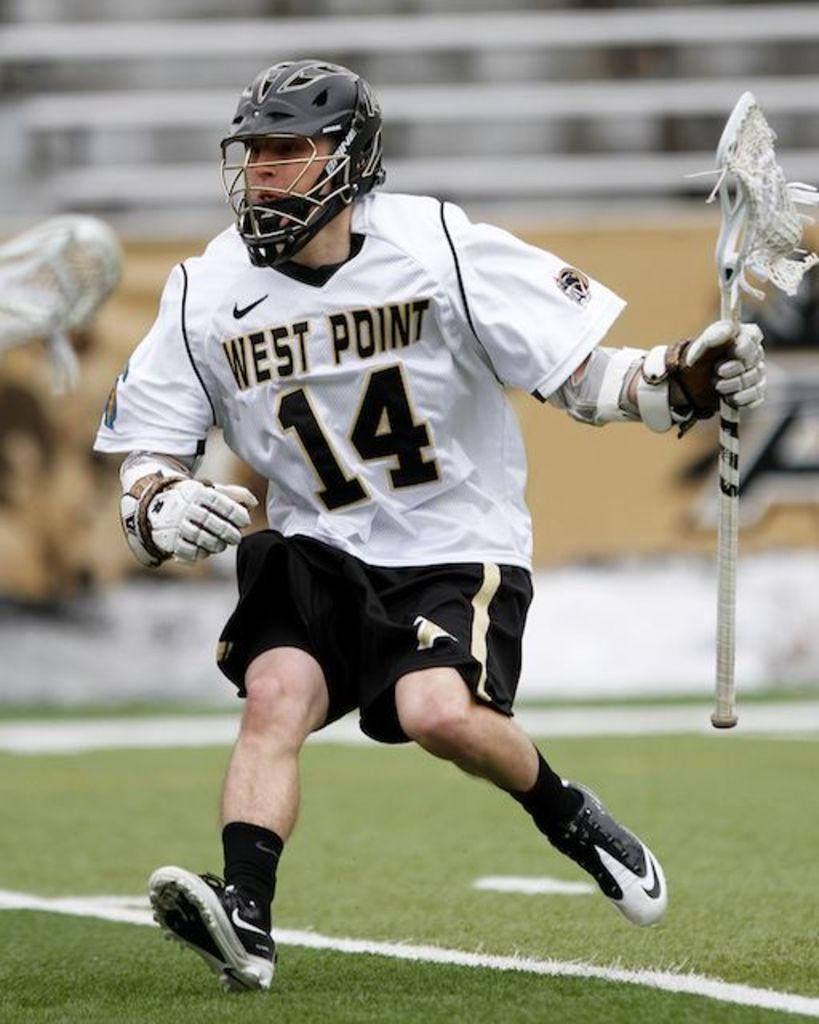What is the main subject of the image? There is a person in the image. What is the person doing in the image? The person is running. What is the person holding in his hand? The person is holding a stick in his hand. Can you describe the background of the image? The background of the image is blurred. What type of terrain is visible at the bottom of the image? There is grass visible at the bottom of the image. Can you tell me how many kittens are playing impulsively in the grass in the image? There are no kittens present in the image, and the person is running, not playing impulsively. 